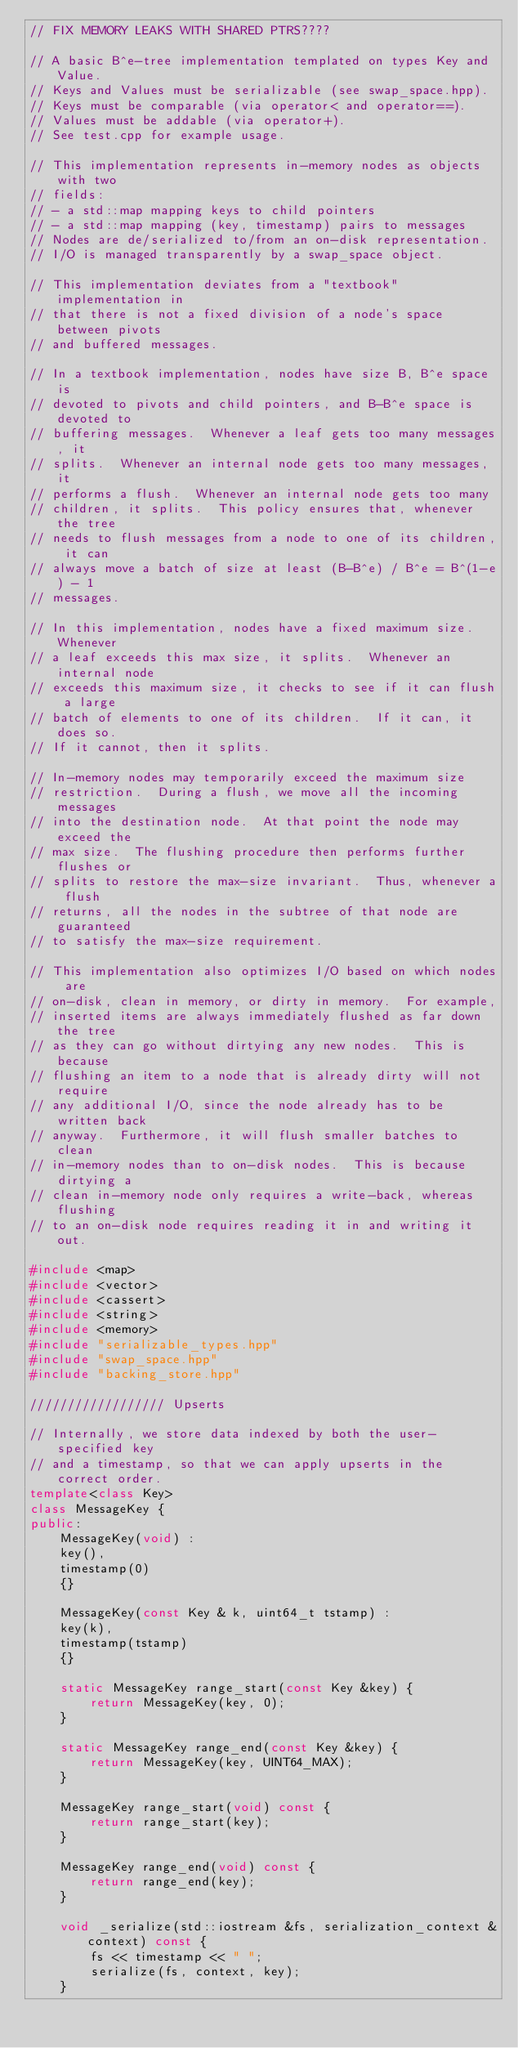<code> <loc_0><loc_0><loc_500><loc_500><_C++_>// FIX MEMORY LEAKS WITH SHARED PTRS????

// A basic B^e-tree implementation templated on types Key and Value.
// Keys and Values must be serializable (see swap_space.hpp).
// Keys must be comparable (via operator< and operator==).
// Values must be addable (via operator+).
// See test.cpp for example usage.

// This implementation represents in-memory nodes as objects with two
// fields:
// - a std::map mapping keys to child pointers
// - a std::map mapping (key, timestamp) pairs to messages
// Nodes are de/serialized to/from an on-disk representation.
// I/O is managed transparently by a swap_space object.

// This implementation deviates from a "textbook" implementation in
// that there is not a fixed division of a node's space between pivots
// and buffered messages.

// In a textbook implementation, nodes have size B, B^e space is
// devoted to pivots and child pointers, and B-B^e space is devoted to
// buffering messages.  Whenever a leaf gets too many messages, it
// splits.  Whenever an internal node gets too many messages, it
// performs a flush.  Whenever an internal node gets too many
// children, it splits.  This policy ensures that, whenever the tree
// needs to flush messages from a node to one of its children, it can
// always move a batch of size at least (B-B^e) / B^e = B^(1-e) - 1
// messages.

// In this implementation, nodes have a fixed maximum size.  Whenever
// a leaf exceeds this max size, it splits.  Whenever an internal node
// exceeds this maximum size, it checks to see if it can flush a large
// batch of elements to one of its children.  If it can, it does so.
// If it cannot, then it splits.

// In-memory nodes may temporarily exceed the maximum size
// restriction.  During a flush, we move all the incoming messages
// into the destination node.  At that point the node may exceed the
// max size.  The flushing procedure then performs further flushes or
// splits to restore the max-size invariant.  Thus, whenever a flush
// returns, all the nodes in the subtree of that node are guaranteed
// to satisfy the max-size requirement.

// This implementation also optimizes I/O based on which nodes are
// on-disk, clean in memory, or dirty in memory.  For example,
// inserted items are always immediately flushed as far down the tree
// as they can go without dirtying any new nodes.  This is because
// flushing an item to a node that is already dirty will not require
// any additional I/O, since the node already has to be written back
// anyway.  Furthermore, it will flush smaller batches to clean
// in-memory nodes than to on-disk nodes.  This is because dirtying a
// clean in-memory node only requires a write-back, whereas flushing
// to an on-disk node requires reading it in and writing it out.

#include <map>
#include <vector>
#include <cassert>
#include <string>
#include <memory>
#include "serializable_types.hpp"
#include "swap_space.hpp"
#include "backing_store.hpp"

////////////////// Upserts

// Internally, we store data indexed by both the user-specified key
// and a timestamp, so that we can apply upserts in the correct order.
template<class Key>
class MessageKey {
public:
    MessageKey(void) :
    key(),
    timestamp(0)
    {}
    
    MessageKey(const Key & k, uint64_t tstamp) :
    key(k),
    timestamp(tstamp)
    {}
    
    static MessageKey range_start(const Key &key) {
        return MessageKey(key, 0);
    }
    
    static MessageKey range_end(const Key &key) {
        return MessageKey(key, UINT64_MAX);
    }
    
    MessageKey range_start(void) const {
        return range_start(key);
    }
    
    MessageKey range_end(void) const {
        return range_end(key);
    }
    
    void _serialize(std::iostream &fs, serialization_context &context) const {
        fs << timestamp << " ";
        serialize(fs, context, key);
    }
    </code> 